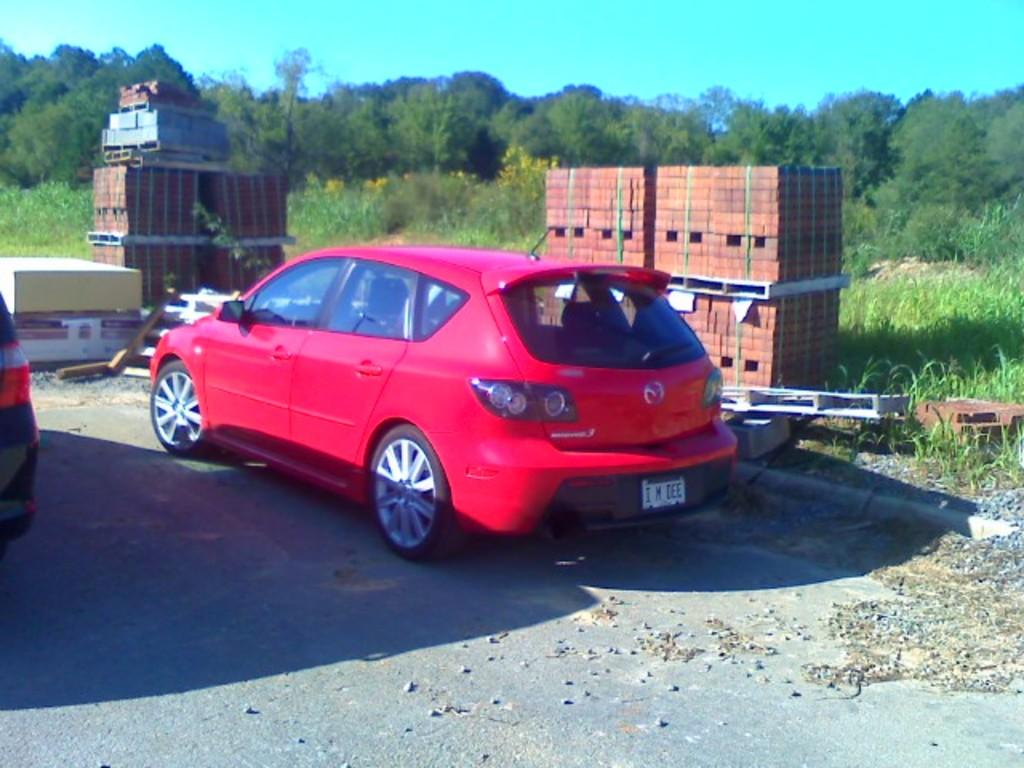What is the main subject of the image? There is a car in the image. Where is the car located? The car is on the road. What can be seen in the background of the image? There are trees, bricks, boxes, and the sky visible in the background of the image. What type of hands can be seen holding the steering wheel in the image? There are no hands visible in the image, as the car is not occupied by a driver. 